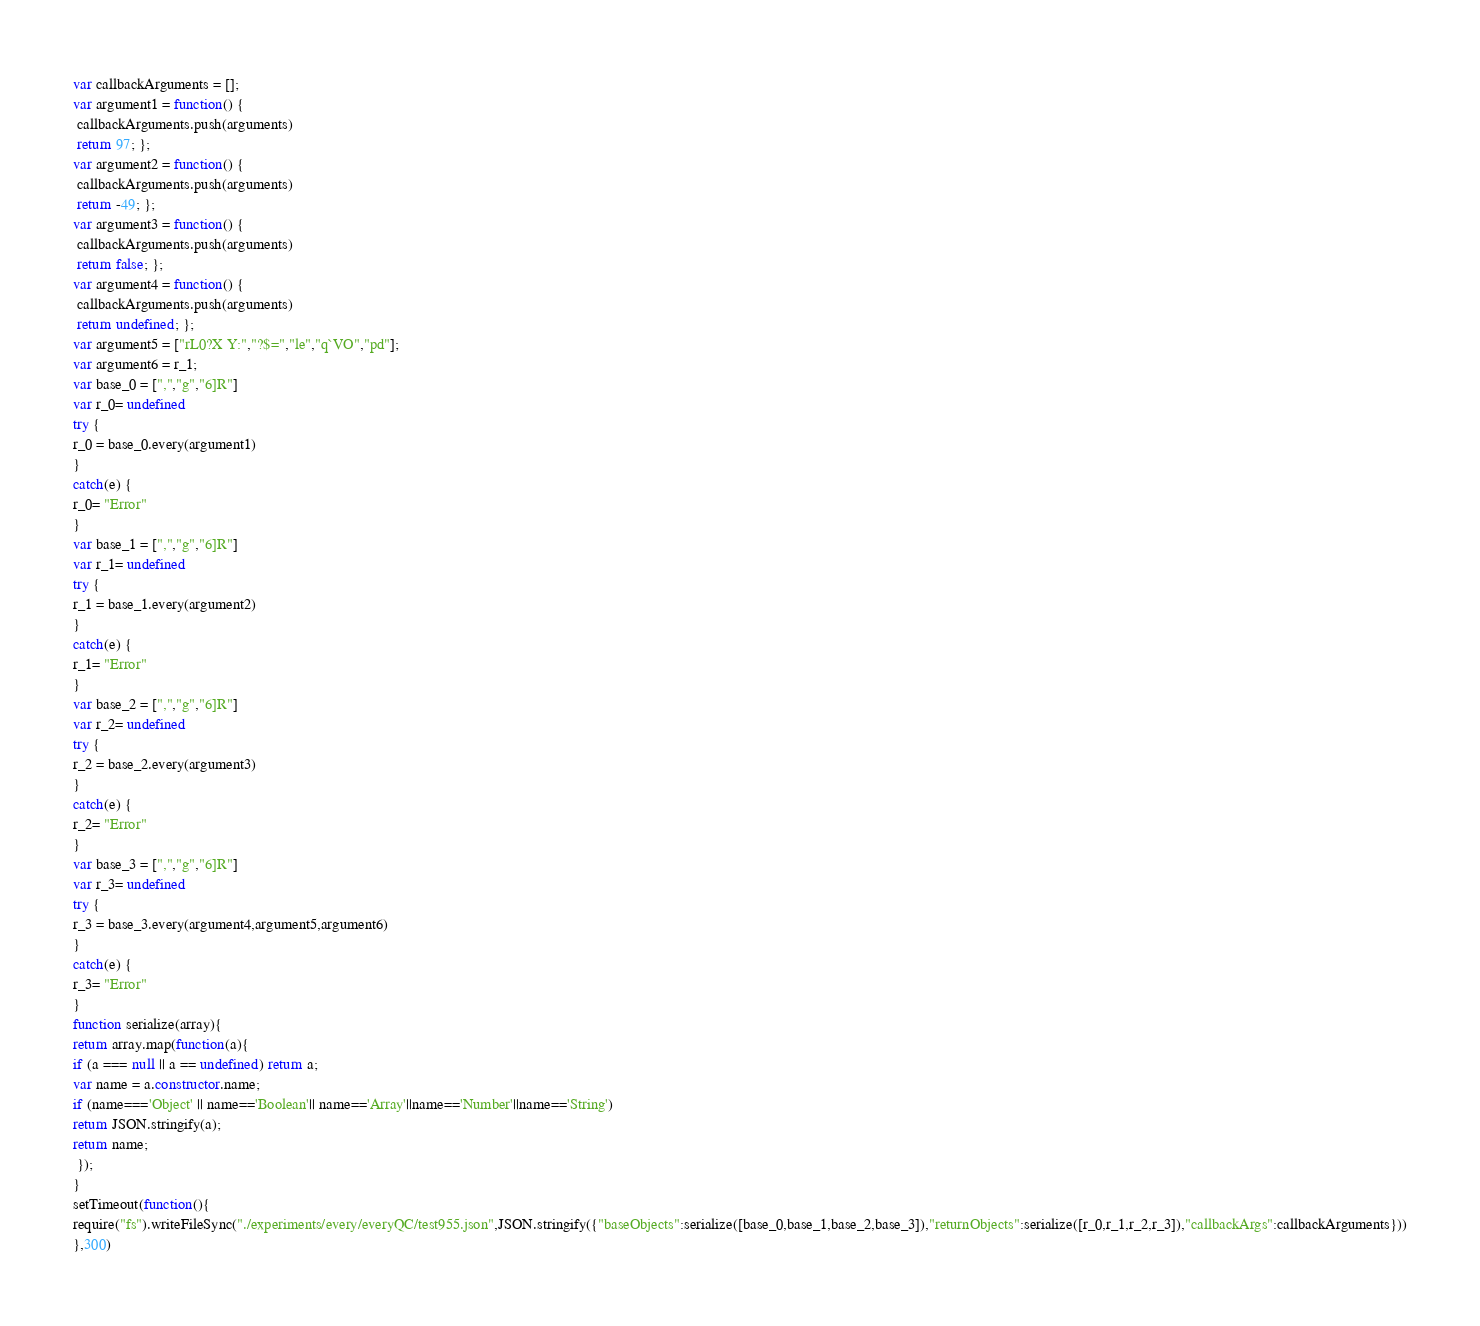Convert code to text. <code><loc_0><loc_0><loc_500><loc_500><_JavaScript_>





var callbackArguments = [];
var argument1 = function() {
 callbackArguments.push(arguments) 
 return 97; };
var argument2 = function() {
 callbackArguments.push(arguments) 
 return -49; };
var argument3 = function() {
 callbackArguments.push(arguments) 
 return false; };
var argument4 = function() {
 callbackArguments.push(arguments) 
 return undefined; };
var argument5 = ["rL0?X Y:","?$=","le","q`VO","pd"];
var argument6 = r_1;
var base_0 = [",","g","6]R"]
var r_0= undefined
try {
r_0 = base_0.every(argument1)
}
catch(e) {
r_0= "Error"
}
var base_1 = [",","g","6]R"]
var r_1= undefined
try {
r_1 = base_1.every(argument2)
}
catch(e) {
r_1= "Error"
}
var base_2 = [",","g","6]R"]
var r_2= undefined
try {
r_2 = base_2.every(argument3)
}
catch(e) {
r_2= "Error"
}
var base_3 = [",","g","6]R"]
var r_3= undefined
try {
r_3 = base_3.every(argument4,argument5,argument6)
}
catch(e) {
r_3= "Error"
}
function serialize(array){
return array.map(function(a){
if (a === null || a == undefined) return a;
var name = a.constructor.name;
if (name==='Object' || name=='Boolean'|| name=='Array'||name=='Number'||name=='String')
return JSON.stringify(a);
return name;
 });
}
setTimeout(function(){
require("fs").writeFileSync("./experiments/every/everyQC/test955.json",JSON.stringify({"baseObjects":serialize([base_0,base_1,base_2,base_3]),"returnObjects":serialize([r_0,r_1,r_2,r_3]),"callbackArgs":callbackArguments}))
},300)</code> 